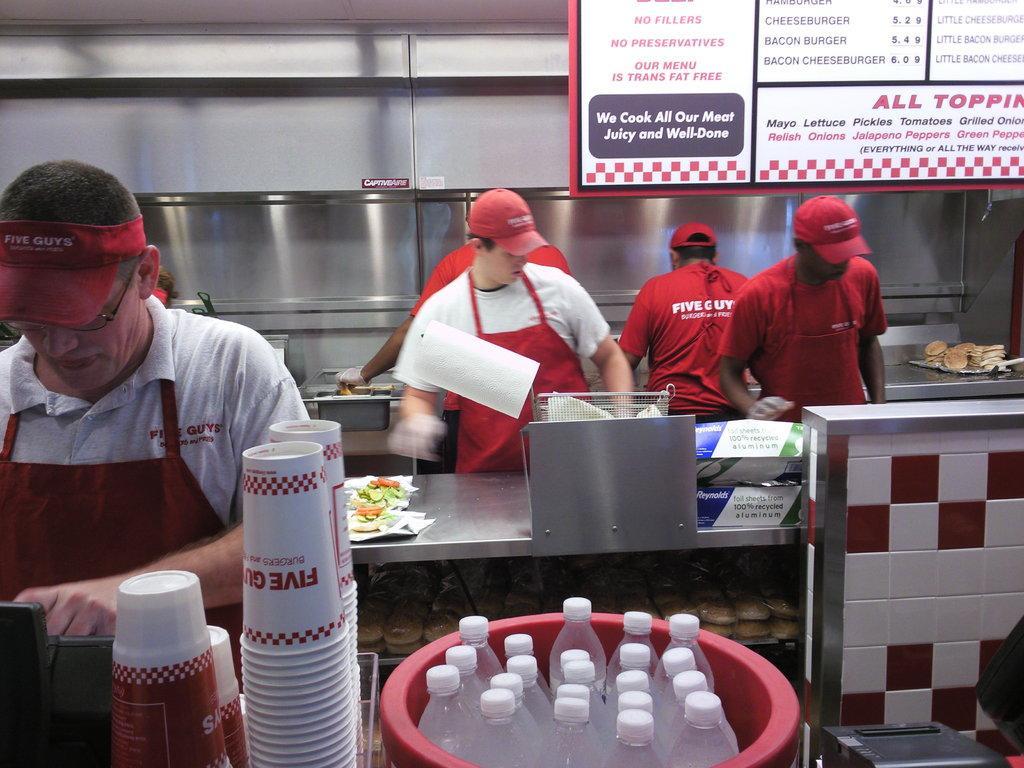In one or two sentences, can you explain what this image depicts? In this image few persons wearing apron are standing behind the table having few vegetable slices on the tray. Right side there is a tray having some food on it. Bottom of image there is a bucket having few bottles in it. Beside there are few cups, beside there is a device. Behind it there is a person wearing red colour apron, cap, spectacles. Right top there is a poster having few lists on it. 